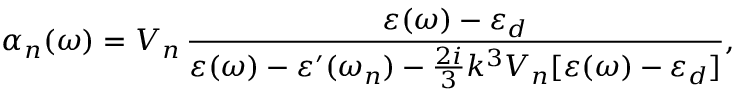Convert formula to latex. <formula><loc_0><loc_0><loc_500><loc_500>\alpha _ { n } ( \omega ) = V _ { n } \, \frac { \varepsilon ( \omega ) - \varepsilon _ { d } } { \varepsilon ( \omega ) - \varepsilon ^ { \prime } ( \omega _ { n } ) - \frac { 2 i } { 3 } k ^ { 3 } V _ { n } [ \varepsilon ( \omega ) - \varepsilon _ { d } ] } ,</formula> 